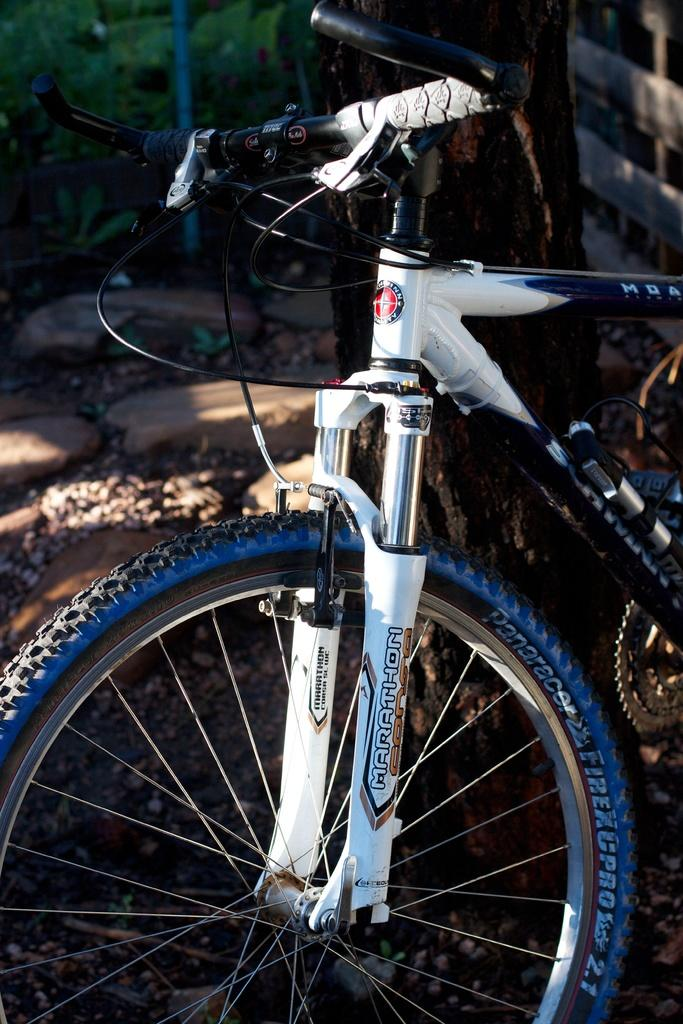What is the main object in the image? There is a bicycle in the image. What else can be seen in the image besides the bicycle? There is a tree trunk, stones, and plants in the image. Can you describe the tree trunk in the image? The tree trunk is a large, vertical piece of wood from a tree. What type of natural elements are present in the image? Stones and plants are the natural elements present in the image. What is the interest rate on the truck in the image? There is no truck present in the image, and therefore no interest rate to discuss. 